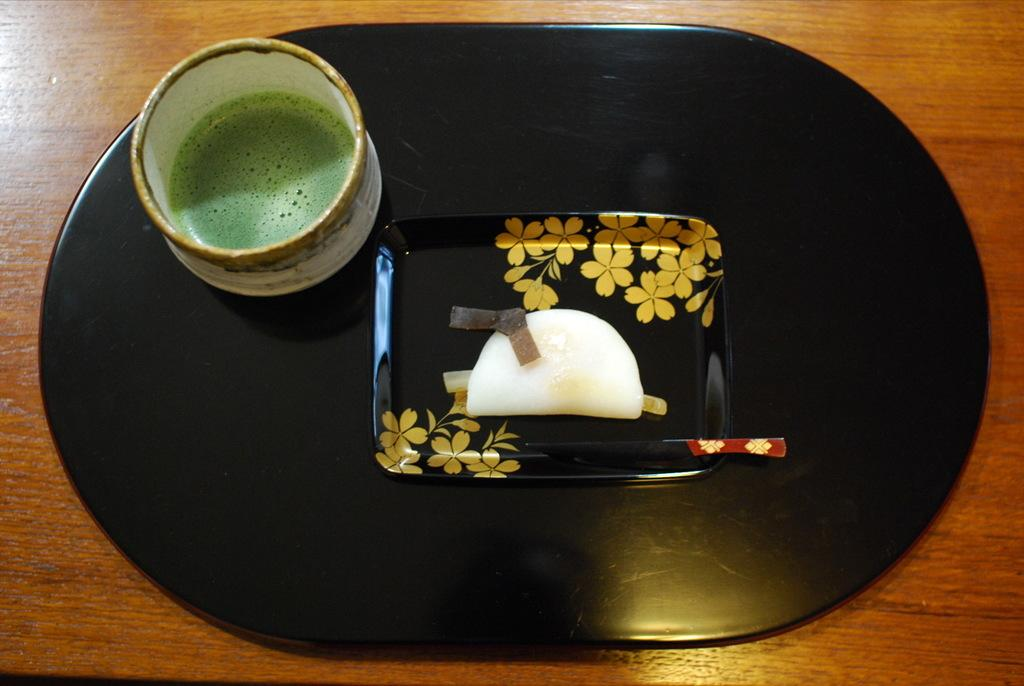What piece of furniture is present in the image? There is a table in the image. What is placed on the table? There is a tray on the table. What is on the tray or table? There is a cup on the table or tray. What type of beetle can be seen crawling on the desk in the image? There is no desk or beetle present in the image. 